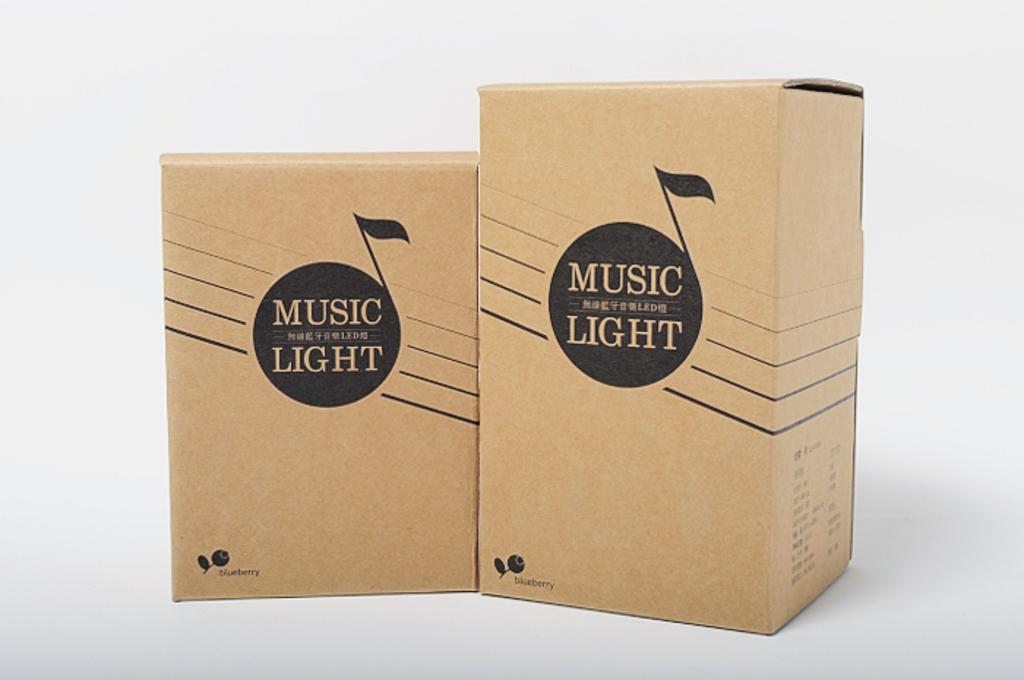What does the black circle say?
Keep it short and to the point. Music light. What is the name in the bottom left corner"?
Make the answer very short. Blueberry. 